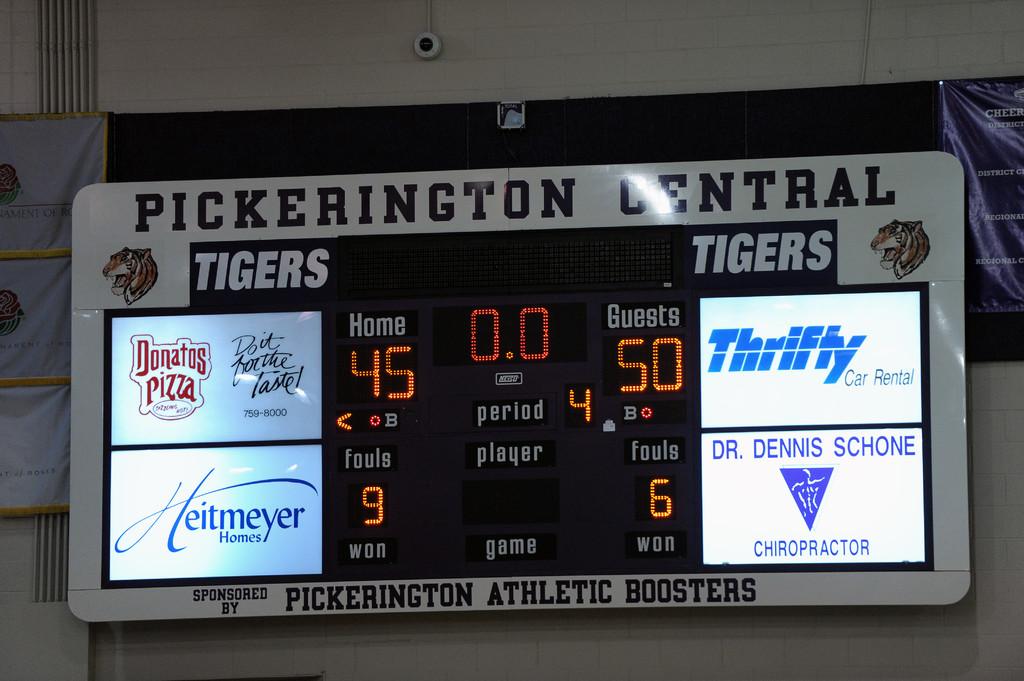What chiropractor is advertised here?
Give a very brief answer. Dr. dennis schone. Who is the sponsor?
Provide a succinct answer. Pickerington athletic boosters. 